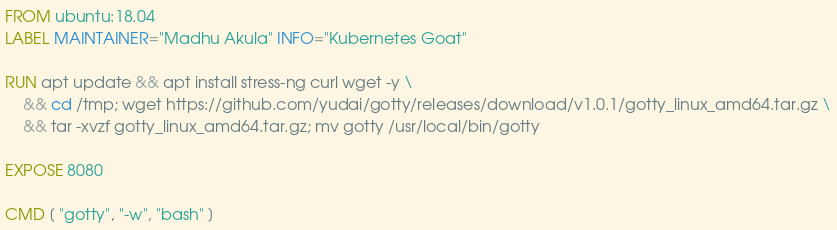Convert code to text. <code><loc_0><loc_0><loc_500><loc_500><_Dockerfile_>FROM ubuntu:18.04
LABEL MAINTAINER="Madhu Akula" INFO="Kubernetes Goat"

RUN apt update && apt install stress-ng curl wget -y \
    && cd /tmp; wget https://github.com/yudai/gotty/releases/download/v1.0.1/gotty_linux_amd64.tar.gz \
    && tar -xvzf gotty_linux_amd64.tar.gz; mv gotty /usr/local/bin/gotty

EXPOSE 8080

CMD [ "gotty", "-w", "bash" ]
</code> 